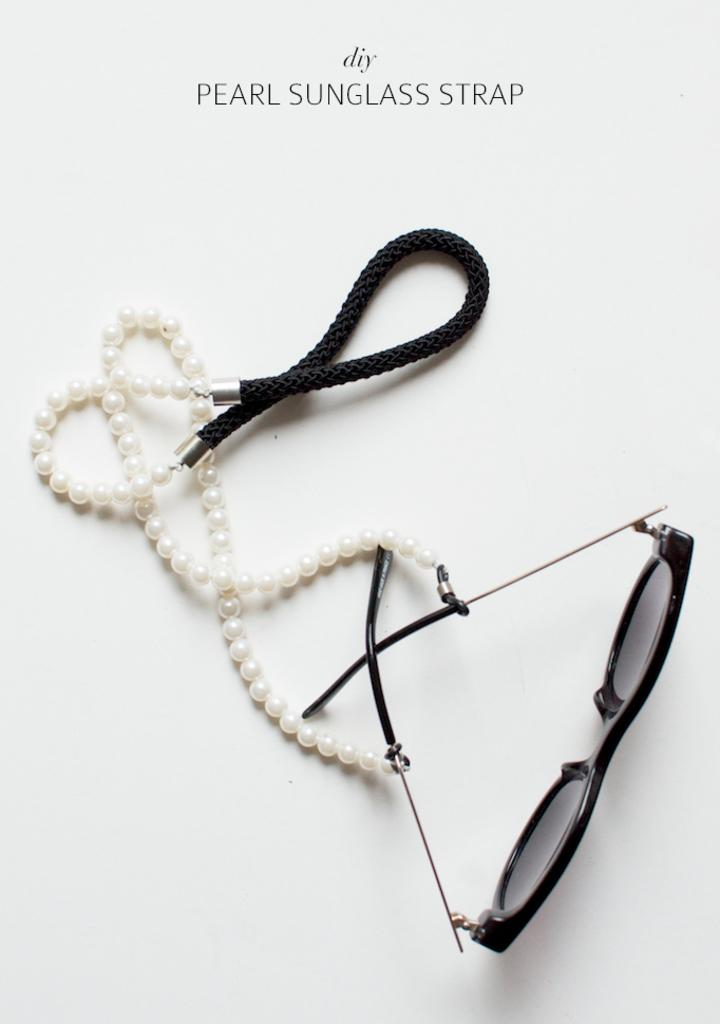What type of accessory is featured in the image? There is a pearl sunglasses strap in the image. How does the pearl sunglasses strap contribute to the education of the person's friend in the image? There is no friend or education mentioned in the image, and the pearl sunglasses strap does not contribute to any educational aspect. 